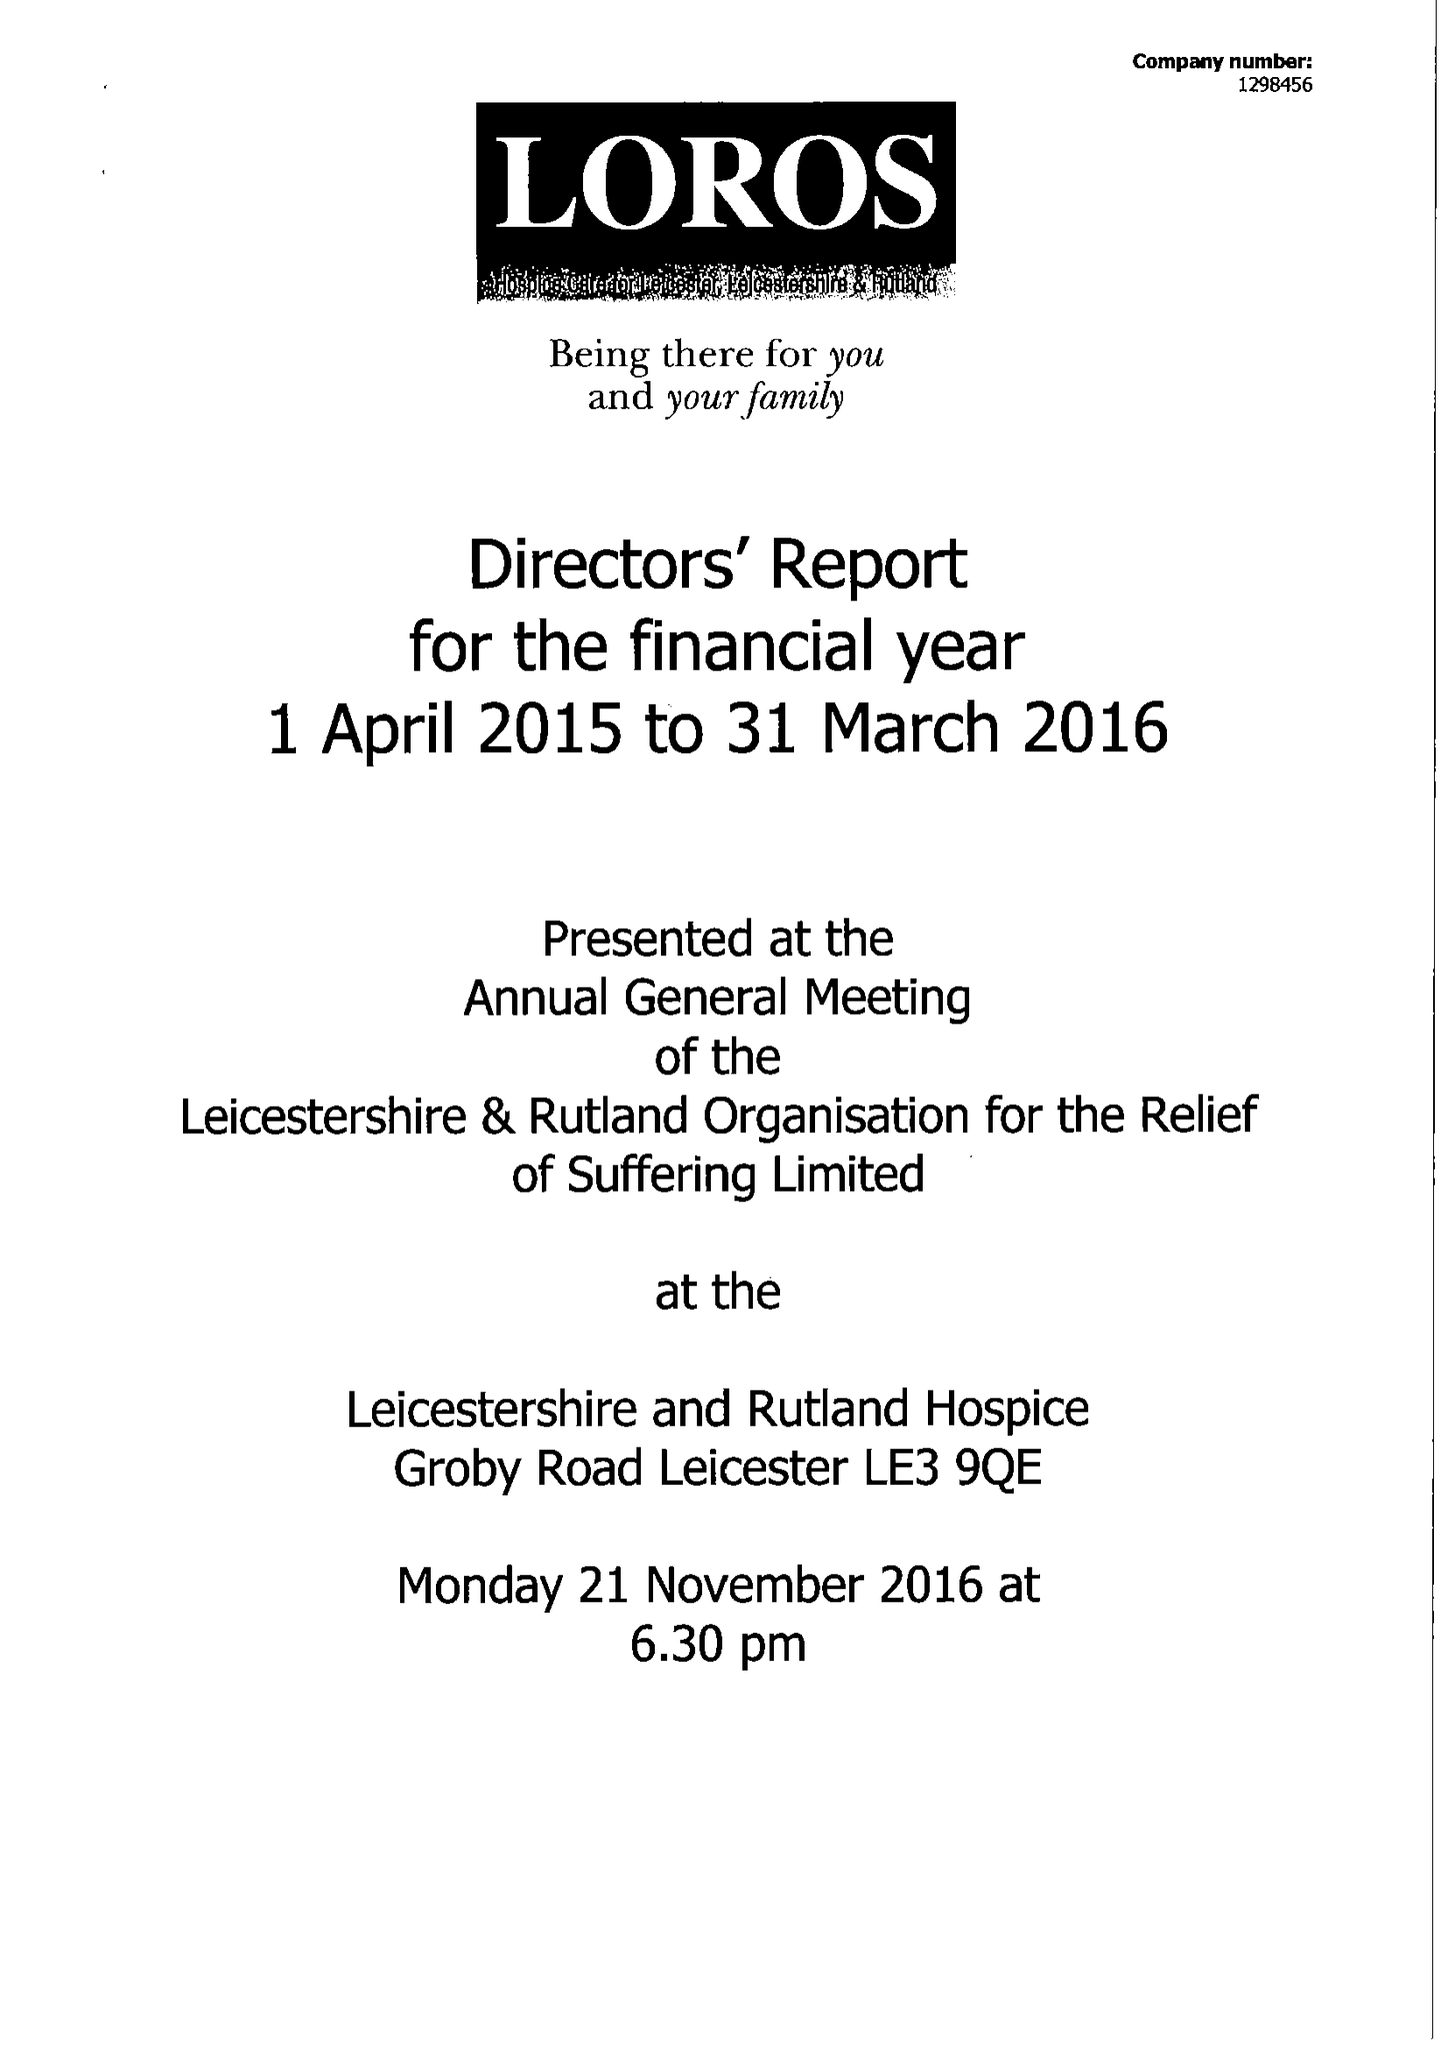What is the value for the report_date?
Answer the question using a single word or phrase. 2016-03-31 